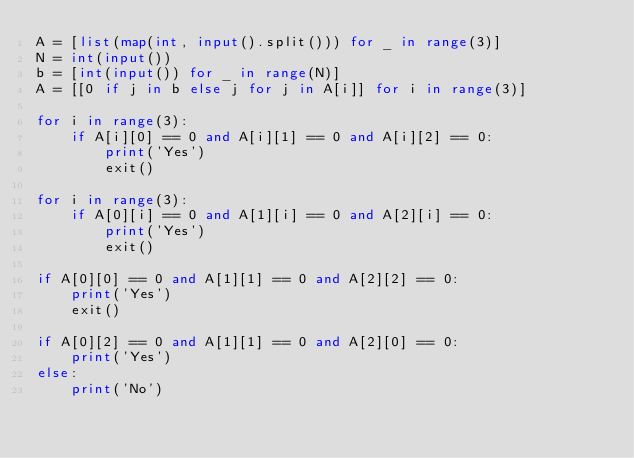Convert code to text. <code><loc_0><loc_0><loc_500><loc_500><_Python_>A = [list(map(int, input().split())) for _ in range(3)]
N = int(input())
b = [int(input()) for _ in range(N)]
A = [[0 if j in b else j for j in A[i]] for i in range(3)]

for i in range(3):
    if A[i][0] == 0 and A[i][1] == 0 and A[i][2] == 0:
        print('Yes')
        exit()

for i in range(3):
    if A[0][i] == 0 and A[1][i] == 0 and A[2][i] == 0:
        print('Yes')
        exit()

if A[0][0] == 0 and A[1][1] == 0 and A[2][2] == 0:
    print('Yes')
    exit()

if A[0][2] == 0 and A[1][1] == 0 and A[2][0] == 0:
    print('Yes')
else:
    print('No')
</code> 